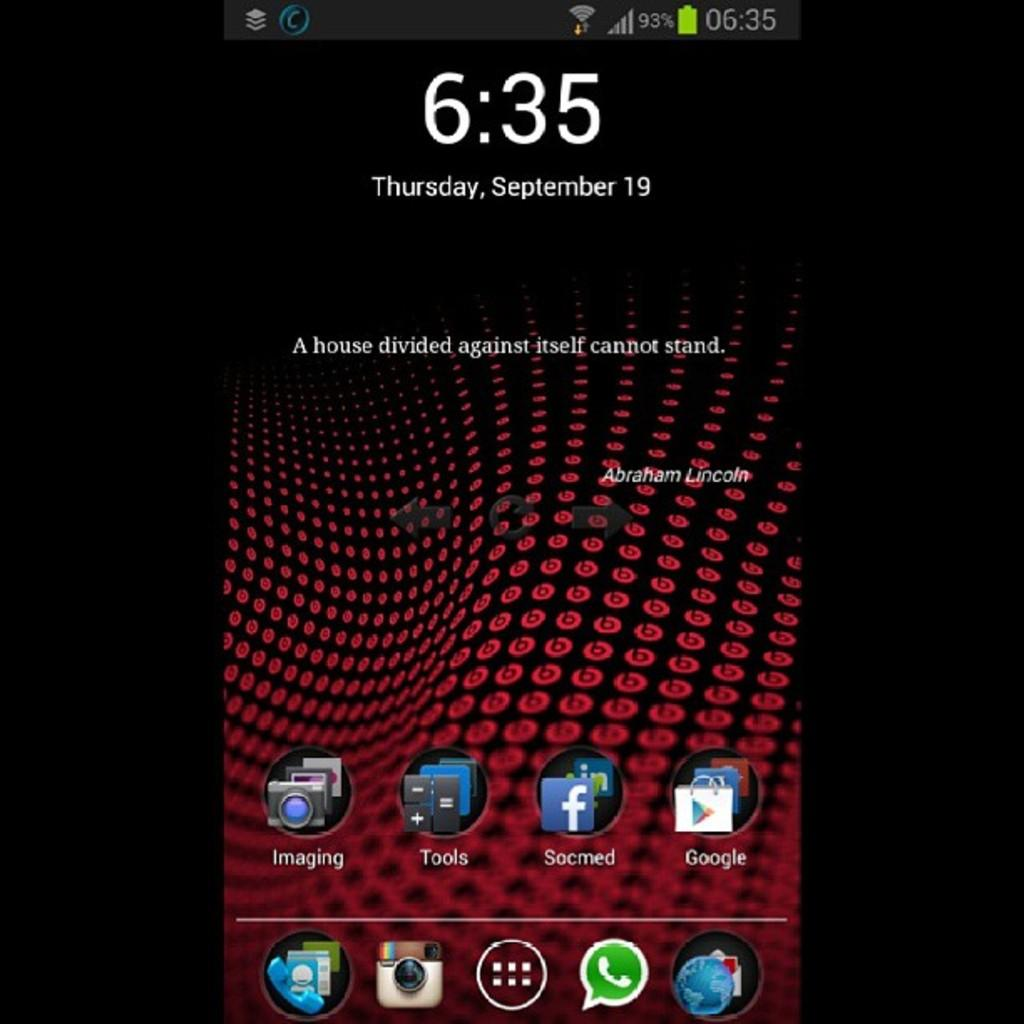<image>
Summarize the visual content of the image. A smartphone screen that shows the time to be 6:35 on September 19. 